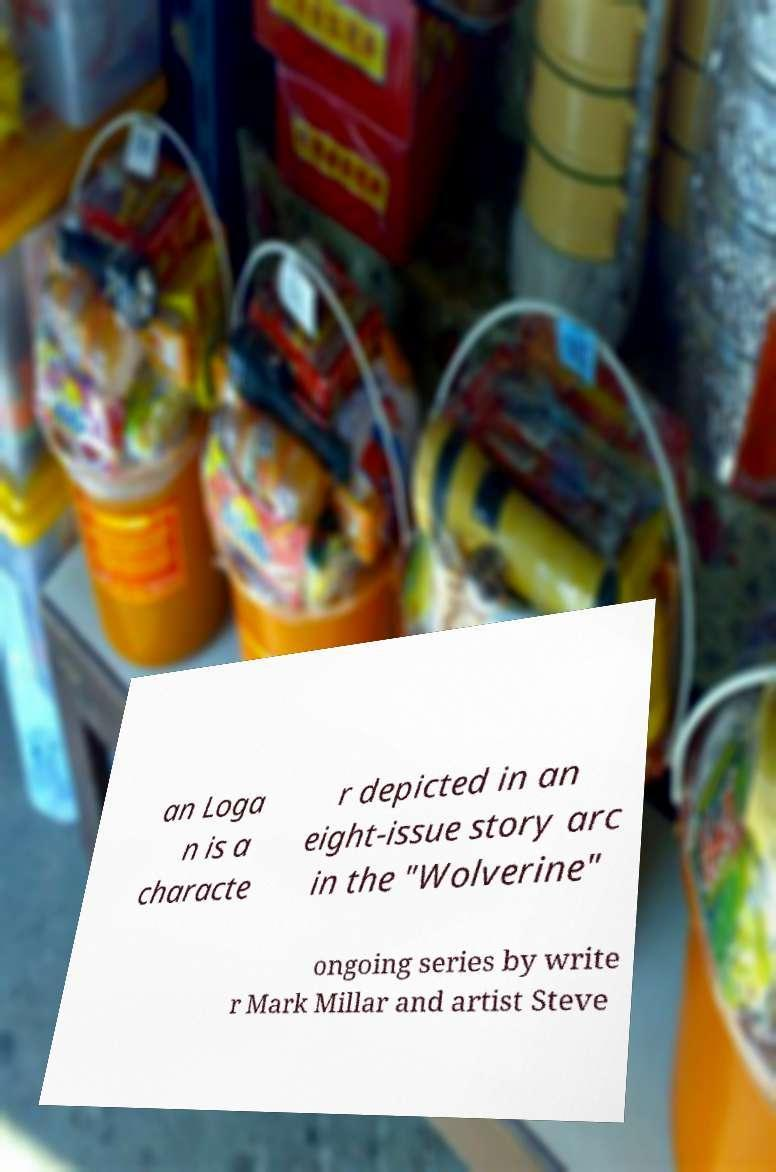Could you assist in decoding the text presented in this image and type it out clearly? an Loga n is a characte r depicted in an eight-issue story arc in the "Wolverine" ongoing series by write r Mark Millar and artist Steve 